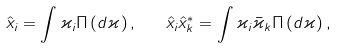<formula> <loc_0><loc_0><loc_500><loc_500>\hat { x } _ { i } = \int \varkappa _ { i } \Pi \left ( d \varkappa \right ) , \quad \hat { x } _ { i } \hat { x } _ { k } ^ { \ast } = \int \varkappa _ { i } \bar { \varkappa } _ { k } \Pi \left ( d \varkappa \right ) ,</formula> 